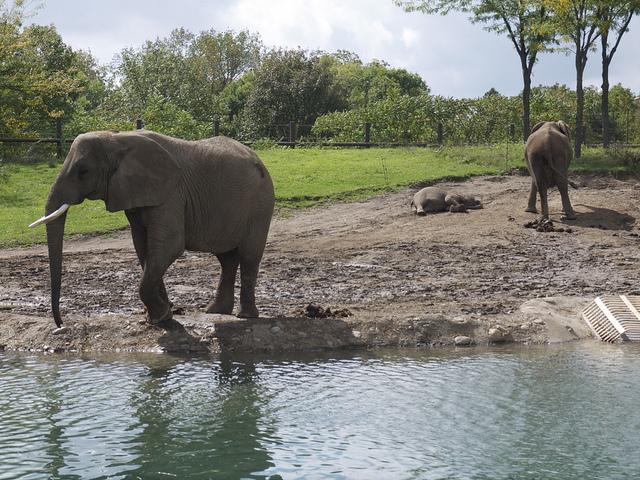How many waves are in the water?
Keep it brief. 0. Is the elephant that is laying down, a very young elephant?
Keep it brief. Yes. Do the legs of one elephant resemble a tripod?
Keep it brief. Yes. How many tails can you see in this picture?
Give a very brief answer. 2. What is between the water and the elephants?
Keep it brief. Dirt. Are the elephants facing toward each other?
Quick response, please. No. Is there a fence by the water?
Be succinct. No. How many elephants are laying down?
Answer briefly. 1. Are these elephants following the adult elephant?
Write a very short answer. No. Are all of the elephants adults?
Quick response, please. No. 